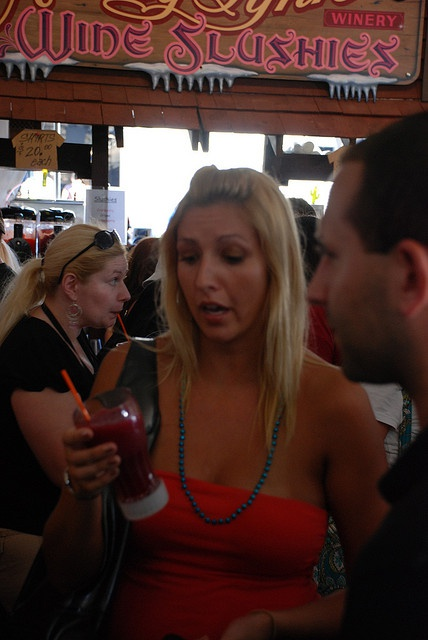Describe the objects in this image and their specific colors. I can see people in maroon, black, and gray tones, people in maroon, black, and gray tones, people in maroon, black, and brown tones, handbag in maroon, black, gray, and darkgray tones, and cup in maroon, black, gray, and purple tones in this image. 